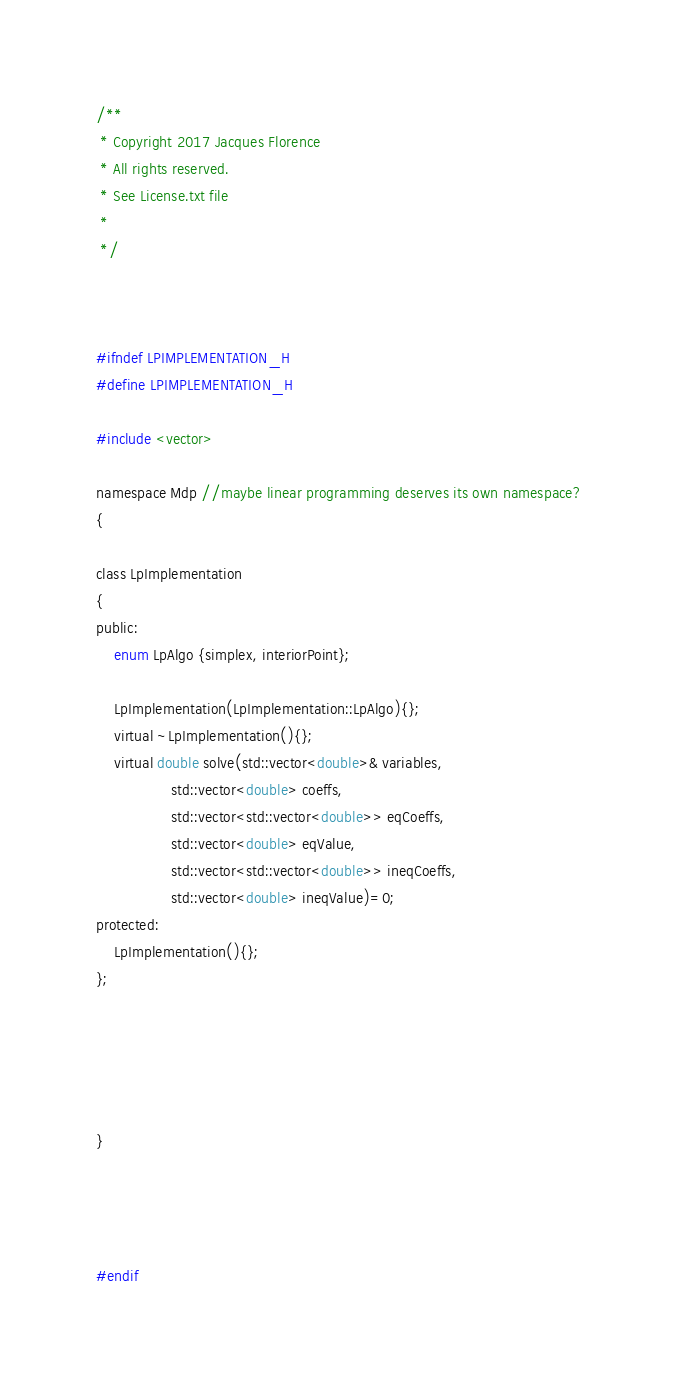<code> <loc_0><loc_0><loc_500><loc_500><_C_>/**
 * Copyright 2017 Jacques Florence
 * All rights reserved.
 * See License.txt file
 *
 */



#ifndef LPIMPLEMENTATION_H
#define LPIMPLEMENTATION_H

#include <vector>

namespace Mdp //maybe linear programming deserves its own namespace?
{

class LpImplementation
{
public:
	enum LpAlgo {simplex, interiorPoint};
	
	LpImplementation(LpImplementation::LpAlgo){};
	virtual ~LpImplementation(){};
	virtual double solve(std::vector<double>& variables,
	             std::vector<double> coeffs,
	             std::vector<std::vector<double>> eqCoeffs,
	             std::vector<double> eqValue,
	             std::vector<std::vector<double>> ineqCoeffs,
	             std::vector<double> ineqValue)=0;
protected:
	LpImplementation(){};
};





}




#endif
</code> 